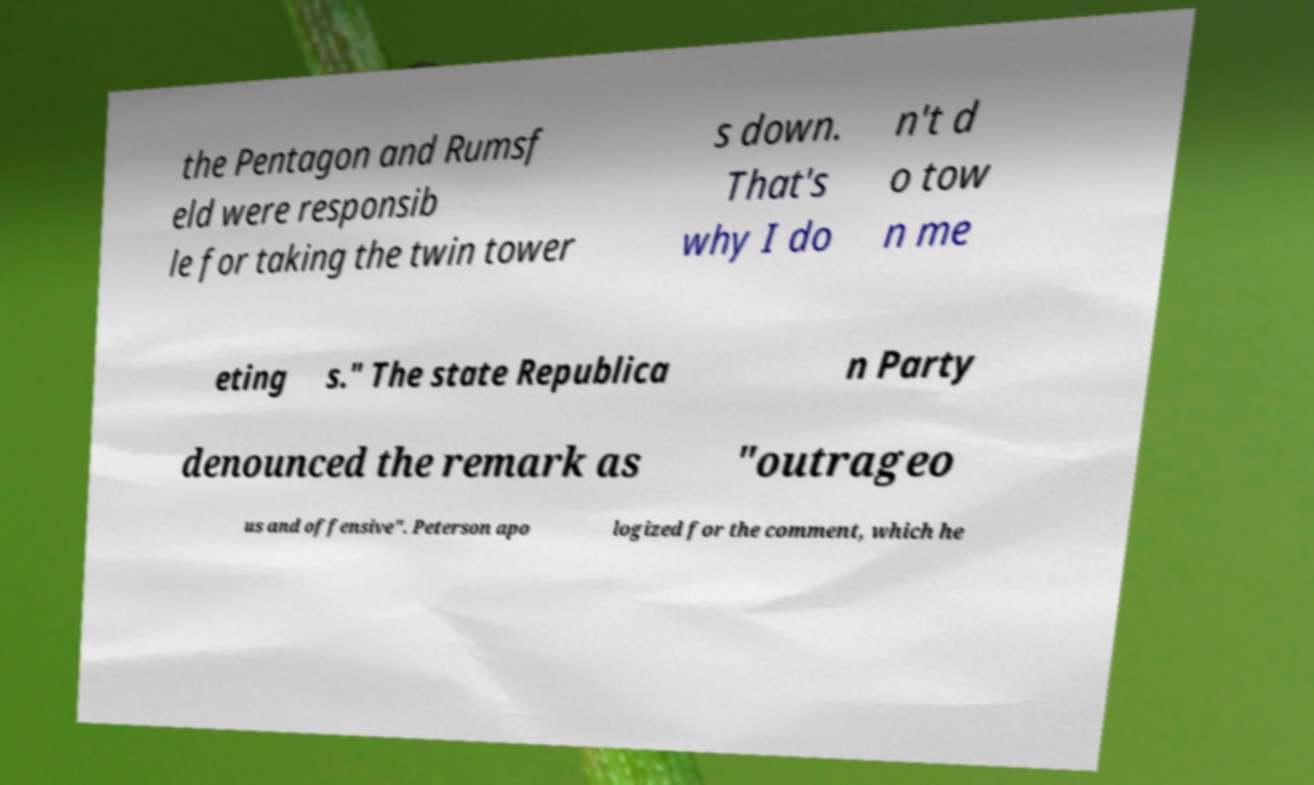Please identify and transcribe the text found in this image. the Pentagon and Rumsf eld were responsib le for taking the twin tower s down. That's why I do n't d o tow n me eting s." The state Republica n Party denounced the remark as "outrageo us and offensive". Peterson apo logized for the comment, which he 